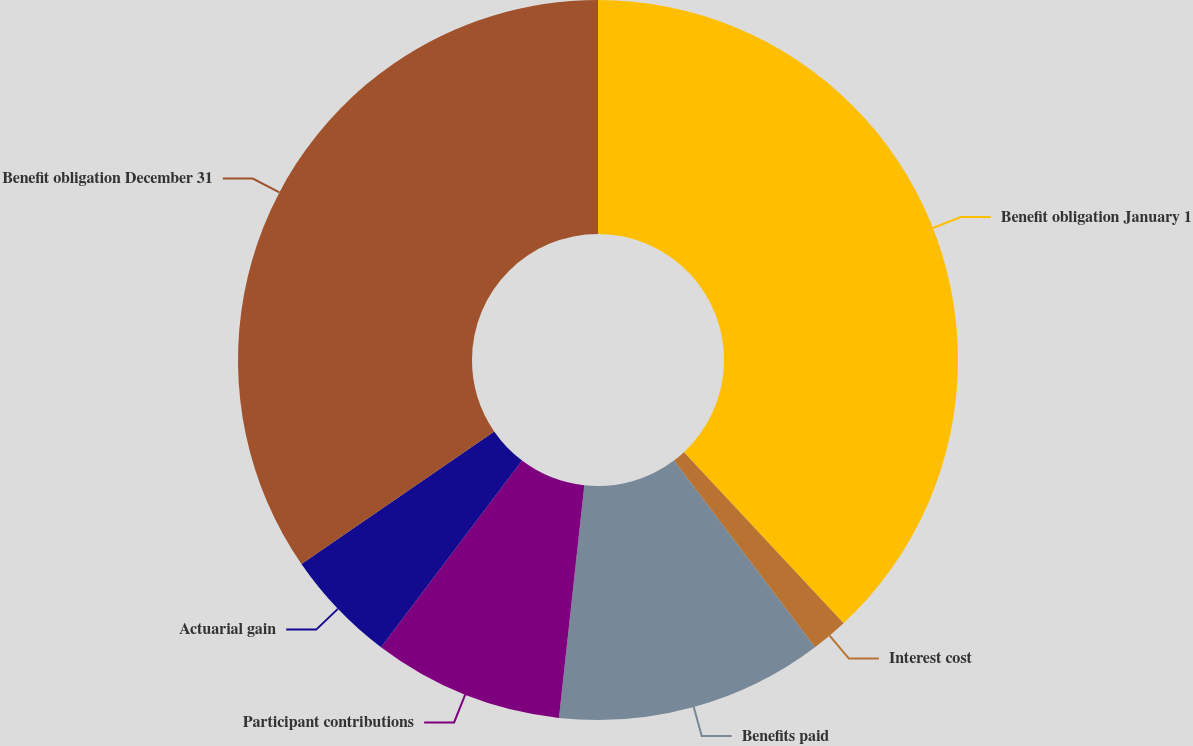<chart> <loc_0><loc_0><loc_500><loc_500><pie_chart><fcel>Benefit obligation January 1<fcel>Interest cost<fcel>Benefits paid<fcel>Participant contributions<fcel>Actuarial gain<fcel>Benefit obligation December 31<nl><fcel>38.06%<fcel>1.65%<fcel>12.03%<fcel>8.57%<fcel>5.11%<fcel>34.6%<nl></chart> 